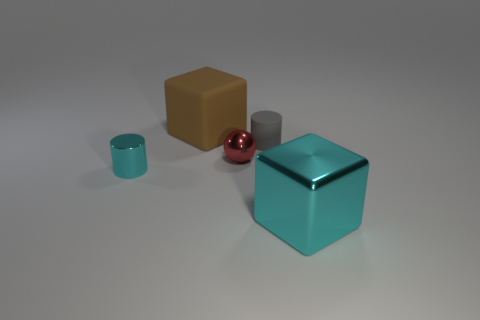Do the brown thing and the large cyan thing have the same shape?
Ensure brevity in your answer.  Yes. Is there any other thing that is the same shape as the red object?
Offer a terse response. No. Is there a tiny blue rubber sphere?
Your answer should be very brief. No. There is a tiny cyan thing; is it the same shape as the small gray thing in front of the brown rubber block?
Make the answer very short. Yes. There is a small cylinder on the right side of the block that is left of the gray thing; what is it made of?
Ensure brevity in your answer.  Rubber. The big shiny block is what color?
Provide a short and direct response. Cyan. There is a tiny metallic object that is to the left of the red object; is its color the same as the large thing to the right of the red metal object?
Make the answer very short. Yes. There is a cyan metal object that is the same shape as the big matte object; what size is it?
Give a very brief answer. Large. Are there any metallic cylinders of the same color as the big shiny block?
Give a very brief answer. Yes. What material is the big block that is the same color as the small metal cylinder?
Give a very brief answer. Metal. 